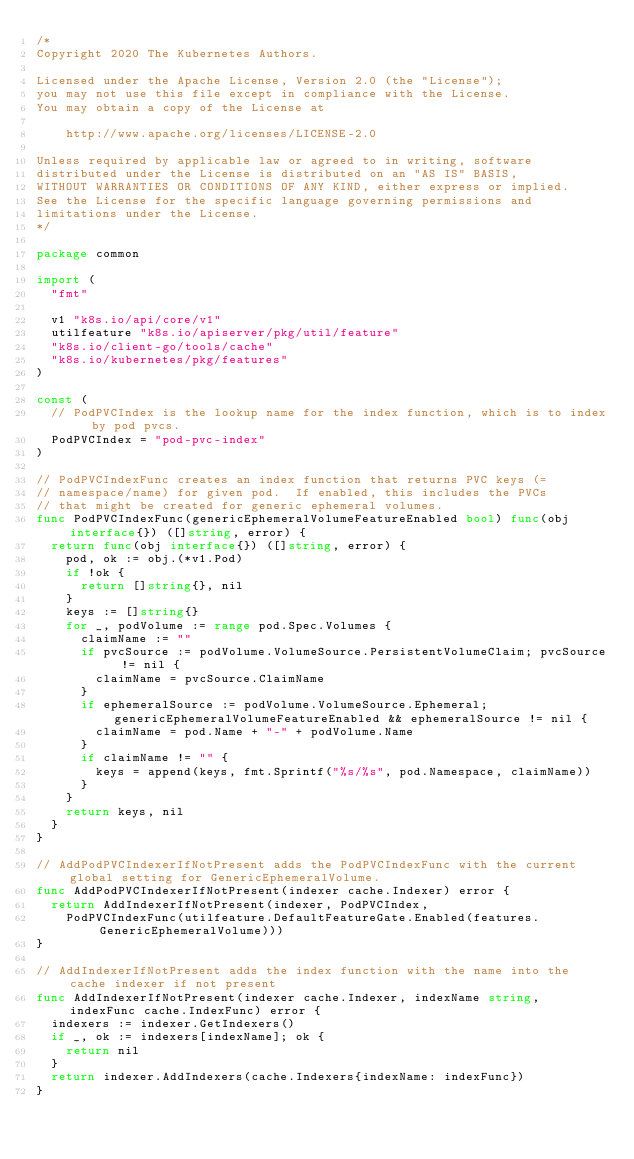<code> <loc_0><loc_0><loc_500><loc_500><_Go_>/*
Copyright 2020 The Kubernetes Authors.

Licensed under the Apache License, Version 2.0 (the "License");
you may not use this file except in compliance with the License.
You may obtain a copy of the License at

    http://www.apache.org/licenses/LICENSE-2.0

Unless required by applicable law or agreed to in writing, software
distributed under the License is distributed on an "AS IS" BASIS,
WITHOUT WARRANTIES OR CONDITIONS OF ANY KIND, either express or implied.
See the License for the specific language governing permissions and
limitations under the License.
*/

package common

import (
	"fmt"

	v1 "k8s.io/api/core/v1"
	utilfeature "k8s.io/apiserver/pkg/util/feature"
	"k8s.io/client-go/tools/cache"
	"k8s.io/kubernetes/pkg/features"
)

const (
	// PodPVCIndex is the lookup name for the index function, which is to index by pod pvcs.
	PodPVCIndex = "pod-pvc-index"
)

// PodPVCIndexFunc creates an index function that returns PVC keys (=
// namespace/name) for given pod.  If enabled, this includes the PVCs
// that might be created for generic ephemeral volumes.
func PodPVCIndexFunc(genericEphemeralVolumeFeatureEnabled bool) func(obj interface{}) ([]string, error) {
	return func(obj interface{}) ([]string, error) {
		pod, ok := obj.(*v1.Pod)
		if !ok {
			return []string{}, nil
		}
		keys := []string{}
		for _, podVolume := range pod.Spec.Volumes {
			claimName := ""
			if pvcSource := podVolume.VolumeSource.PersistentVolumeClaim; pvcSource != nil {
				claimName = pvcSource.ClaimName
			}
			if ephemeralSource := podVolume.VolumeSource.Ephemeral; genericEphemeralVolumeFeatureEnabled && ephemeralSource != nil {
				claimName = pod.Name + "-" + podVolume.Name
			}
			if claimName != "" {
				keys = append(keys, fmt.Sprintf("%s/%s", pod.Namespace, claimName))
			}
		}
		return keys, nil
	}
}

// AddPodPVCIndexerIfNotPresent adds the PodPVCIndexFunc with the current global setting for GenericEphemeralVolume.
func AddPodPVCIndexerIfNotPresent(indexer cache.Indexer) error {
	return AddIndexerIfNotPresent(indexer, PodPVCIndex,
		PodPVCIndexFunc(utilfeature.DefaultFeatureGate.Enabled(features.GenericEphemeralVolume)))
}

// AddIndexerIfNotPresent adds the index function with the name into the cache indexer if not present
func AddIndexerIfNotPresent(indexer cache.Indexer, indexName string, indexFunc cache.IndexFunc) error {
	indexers := indexer.GetIndexers()
	if _, ok := indexers[indexName]; ok {
		return nil
	}
	return indexer.AddIndexers(cache.Indexers{indexName: indexFunc})
}
</code> 